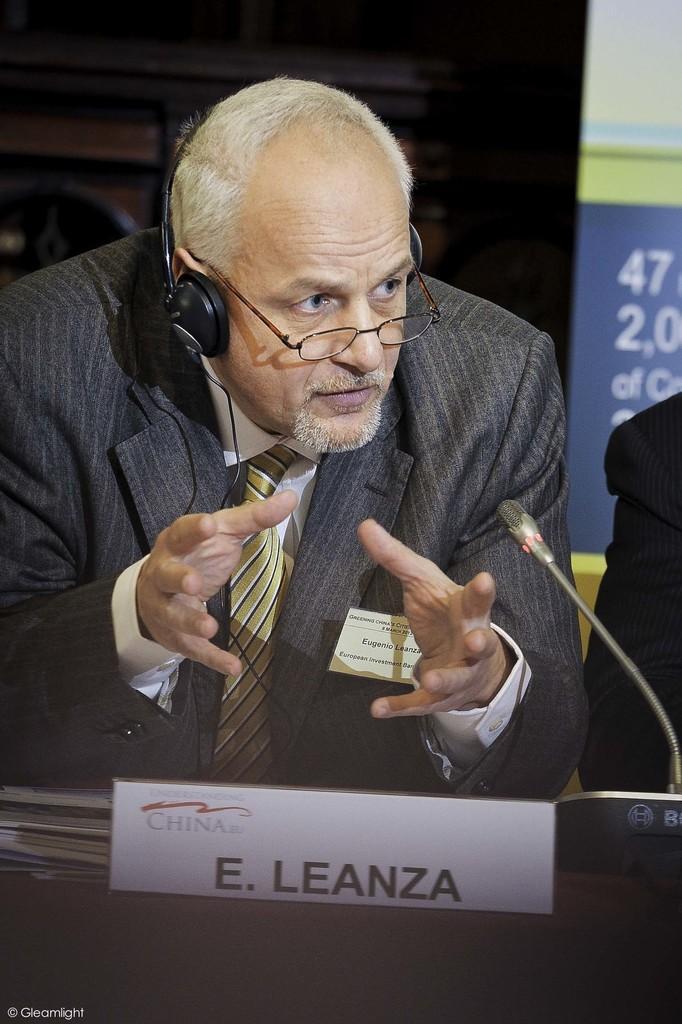How would you summarize this image in a sentence or two? In this image there is a man. In front of him there is a table. He is leaning on the table. He is wearing spectacles and a headphone. In front of him there is a microphone on the table. There is a name board with text on the table. Behind him there is a wall. To the right there is another person. Behind the person there are numbers on the wall. 